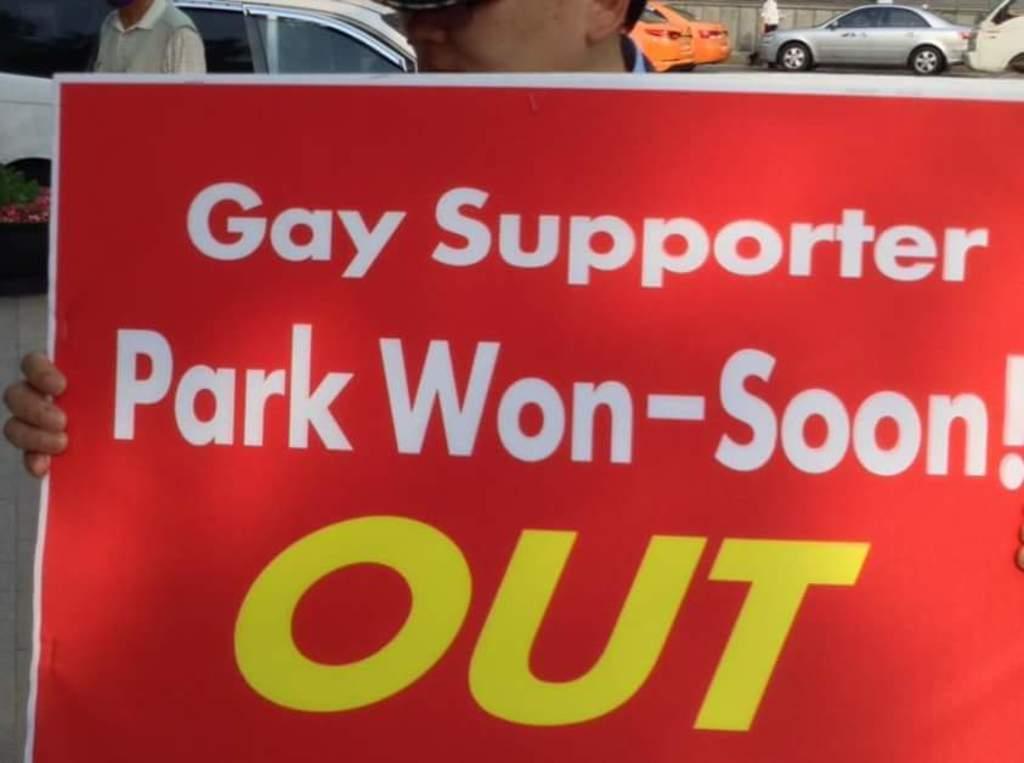Please provide a concise description of this image. In this image we can see a person holding a poster and there is a text on it. In the background, we can see some vehicles and few people. 